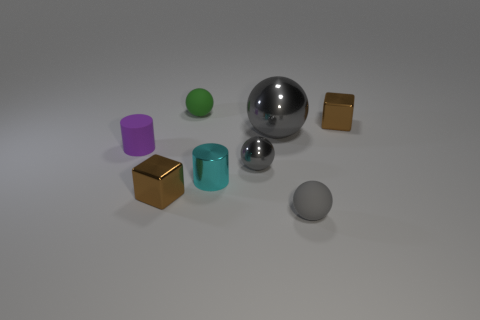Is the number of small rubber objects that are in front of the small cyan cylinder greater than the number of small gray metallic objects to the right of the small gray rubber ball?
Offer a terse response. Yes. What color is the tiny rubber thing to the left of the brown object in front of the big metallic object?
Offer a terse response. Purple. Are there any small shiny objects that have the same color as the large metal ball?
Keep it short and to the point. Yes. There is a object in front of the brown metal object to the left of the green sphere behind the purple matte cylinder; how big is it?
Offer a very short reply. Small. The green matte object has what shape?
Your answer should be very brief. Sphere. What size is the matte sphere that is the same color as the big metallic object?
Your answer should be compact. Small. What number of tiny things are behind the tiny brown thing that is behind the large gray sphere?
Your response must be concise. 1. How many other things are the same material as the large gray thing?
Provide a short and direct response. 4. Does the small cyan cylinder that is left of the small gray matte thing have the same material as the brown thing on the left side of the tiny green thing?
Offer a very short reply. Yes. Is there anything else that has the same shape as the large gray thing?
Ensure brevity in your answer.  Yes. 